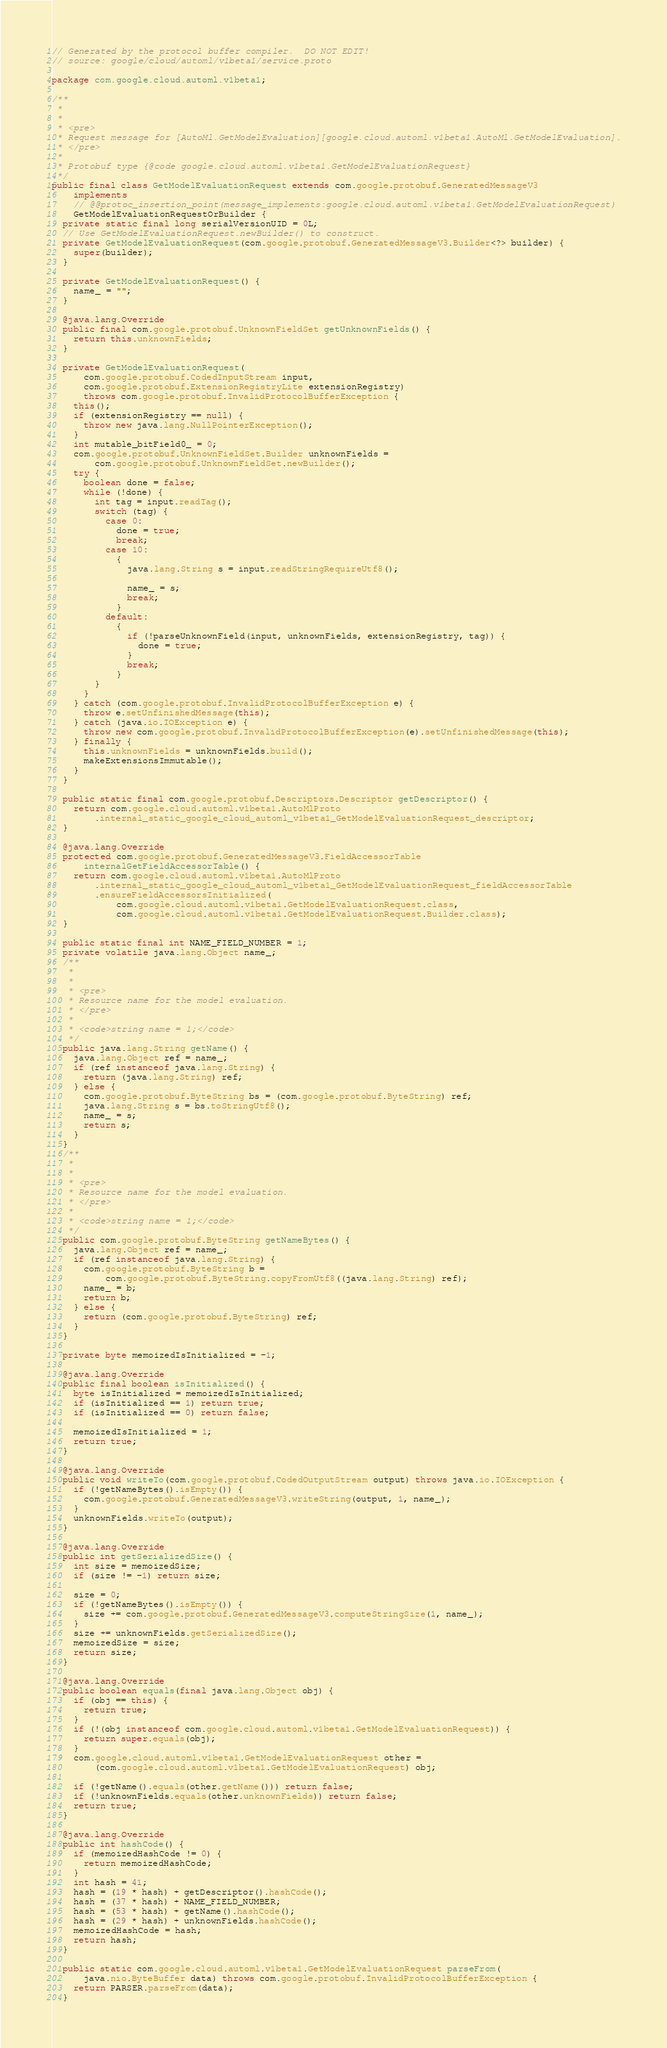Convert code to text. <code><loc_0><loc_0><loc_500><loc_500><_Java_>// Generated by the protocol buffer compiler.  DO NOT EDIT!
// source: google/cloud/automl/v1beta1/service.proto

package com.google.cloud.automl.v1beta1;

/**
 *
 *
 * <pre>
 * Request message for [AutoMl.GetModelEvaluation][google.cloud.automl.v1beta1.AutoMl.GetModelEvaluation].
 * </pre>
 *
 * Protobuf type {@code google.cloud.automl.v1beta1.GetModelEvaluationRequest}
 */
public final class GetModelEvaluationRequest extends com.google.protobuf.GeneratedMessageV3
    implements
    // @@protoc_insertion_point(message_implements:google.cloud.automl.v1beta1.GetModelEvaluationRequest)
    GetModelEvaluationRequestOrBuilder {
  private static final long serialVersionUID = 0L;
  // Use GetModelEvaluationRequest.newBuilder() to construct.
  private GetModelEvaluationRequest(com.google.protobuf.GeneratedMessageV3.Builder<?> builder) {
    super(builder);
  }

  private GetModelEvaluationRequest() {
    name_ = "";
  }

  @java.lang.Override
  public final com.google.protobuf.UnknownFieldSet getUnknownFields() {
    return this.unknownFields;
  }

  private GetModelEvaluationRequest(
      com.google.protobuf.CodedInputStream input,
      com.google.protobuf.ExtensionRegistryLite extensionRegistry)
      throws com.google.protobuf.InvalidProtocolBufferException {
    this();
    if (extensionRegistry == null) {
      throw new java.lang.NullPointerException();
    }
    int mutable_bitField0_ = 0;
    com.google.protobuf.UnknownFieldSet.Builder unknownFields =
        com.google.protobuf.UnknownFieldSet.newBuilder();
    try {
      boolean done = false;
      while (!done) {
        int tag = input.readTag();
        switch (tag) {
          case 0:
            done = true;
            break;
          case 10:
            {
              java.lang.String s = input.readStringRequireUtf8();

              name_ = s;
              break;
            }
          default:
            {
              if (!parseUnknownField(input, unknownFields, extensionRegistry, tag)) {
                done = true;
              }
              break;
            }
        }
      }
    } catch (com.google.protobuf.InvalidProtocolBufferException e) {
      throw e.setUnfinishedMessage(this);
    } catch (java.io.IOException e) {
      throw new com.google.protobuf.InvalidProtocolBufferException(e).setUnfinishedMessage(this);
    } finally {
      this.unknownFields = unknownFields.build();
      makeExtensionsImmutable();
    }
  }

  public static final com.google.protobuf.Descriptors.Descriptor getDescriptor() {
    return com.google.cloud.automl.v1beta1.AutoMlProto
        .internal_static_google_cloud_automl_v1beta1_GetModelEvaluationRequest_descriptor;
  }

  @java.lang.Override
  protected com.google.protobuf.GeneratedMessageV3.FieldAccessorTable
      internalGetFieldAccessorTable() {
    return com.google.cloud.automl.v1beta1.AutoMlProto
        .internal_static_google_cloud_automl_v1beta1_GetModelEvaluationRequest_fieldAccessorTable
        .ensureFieldAccessorsInitialized(
            com.google.cloud.automl.v1beta1.GetModelEvaluationRequest.class,
            com.google.cloud.automl.v1beta1.GetModelEvaluationRequest.Builder.class);
  }

  public static final int NAME_FIELD_NUMBER = 1;
  private volatile java.lang.Object name_;
  /**
   *
   *
   * <pre>
   * Resource name for the model evaluation.
   * </pre>
   *
   * <code>string name = 1;</code>
   */
  public java.lang.String getName() {
    java.lang.Object ref = name_;
    if (ref instanceof java.lang.String) {
      return (java.lang.String) ref;
    } else {
      com.google.protobuf.ByteString bs = (com.google.protobuf.ByteString) ref;
      java.lang.String s = bs.toStringUtf8();
      name_ = s;
      return s;
    }
  }
  /**
   *
   *
   * <pre>
   * Resource name for the model evaluation.
   * </pre>
   *
   * <code>string name = 1;</code>
   */
  public com.google.protobuf.ByteString getNameBytes() {
    java.lang.Object ref = name_;
    if (ref instanceof java.lang.String) {
      com.google.protobuf.ByteString b =
          com.google.protobuf.ByteString.copyFromUtf8((java.lang.String) ref);
      name_ = b;
      return b;
    } else {
      return (com.google.protobuf.ByteString) ref;
    }
  }

  private byte memoizedIsInitialized = -1;

  @java.lang.Override
  public final boolean isInitialized() {
    byte isInitialized = memoizedIsInitialized;
    if (isInitialized == 1) return true;
    if (isInitialized == 0) return false;

    memoizedIsInitialized = 1;
    return true;
  }

  @java.lang.Override
  public void writeTo(com.google.protobuf.CodedOutputStream output) throws java.io.IOException {
    if (!getNameBytes().isEmpty()) {
      com.google.protobuf.GeneratedMessageV3.writeString(output, 1, name_);
    }
    unknownFields.writeTo(output);
  }

  @java.lang.Override
  public int getSerializedSize() {
    int size = memoizedSize;
    if (size != -1) return size;

    size = 0;
    if (!getNameBytes().isEmpty()) {
      size += com.google.protobuf.GeneratedMessageV3.computeStringSize(1, name_);
    }
    size += unknownFields.getSerializedSize();
    memoizedSize = size;
    return size;
  }

  @java.lang.Override
  public boolean equals(final java.lang.Object obj) {
    if (obj == this) {
      return true;
    }
    if (!(obj instanceof com.google.cloud.automl.v1beta1.GetModelEvaluationRequest)) {
      return super.equals(obj);
    }
    com.google.cloud.automl.v1beta1.GetModelEvaluationRequest other =
        (com.google.cloud.automl.v1beta1.GetModelEvaluationRequest) obj;

    if (!getName().equals(other.getName())) return false;
    if (!unknownFields.equals(other.unknownFields)) return false;
    return true;
  }

  @java.lang.Override
  public int hashCode() {
    if (memoizedHashCode != 0) {
      return memoizedHashCode;
    }
    int hash = 41;
    hash = (19 * hash) + getDescriptor().hashCode();
    hash = (37 * hash) + NAME_FIELD_NUMBER;
    hash = (53 * hash) + getName().hashCode();
    hash = (29 * hash) + unknownFields.hashCode();
    memoizedHashCode = hash;
    return hash;
  }

  public static com.google.cloud.automl.v1beta1.GetModelEvaluationRequest parseFrom(
      java.nio.ByteBuffer data) throws com.google.protobuf.InvalidProtocolBufferException {
    return PARSER.parseFrom(data);
  }
</code> 